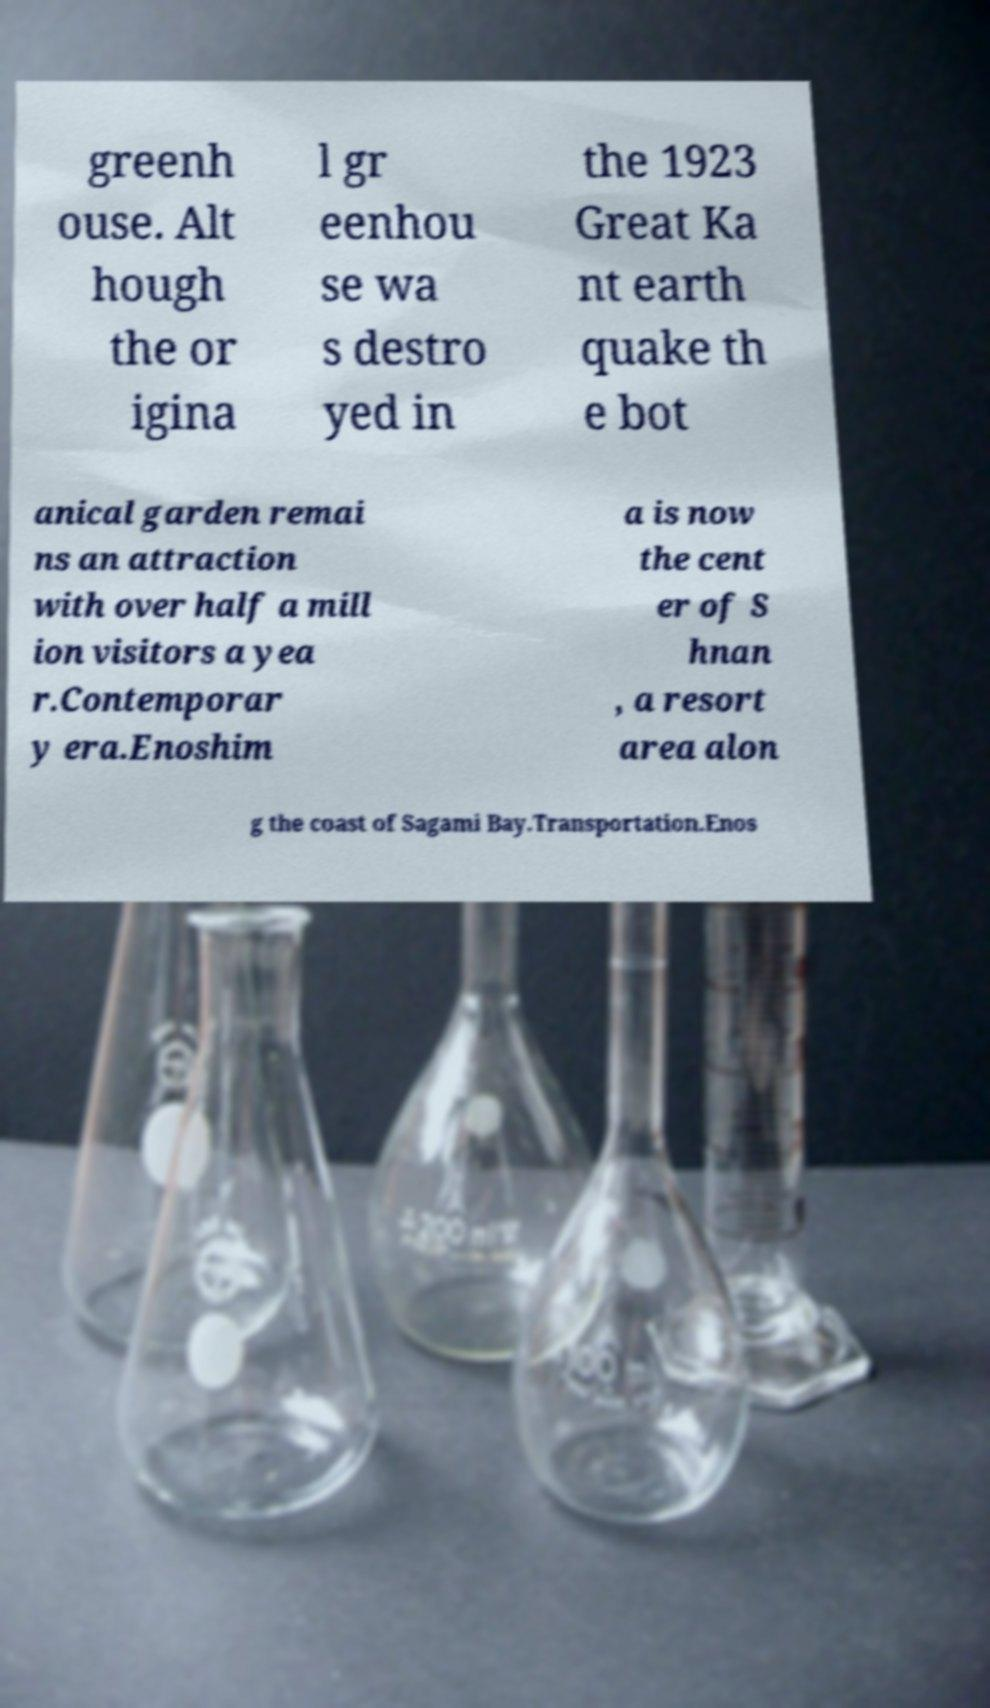There's text embedded in this image that I need extracted. Can you transcribe it verbatim? greenh ouse. Alt hough the or igina l gr eenhou se wa s destro yed in the 1923 Great Ka nt earth quake th e bot anical garden remai ns an attraction with over half a mill ion visitors a yea r.Contemporar y era.Enoshim a is now the cent er of S hnan , a resort area alon g the coast of Sagami Bay.Transportation.Enos 